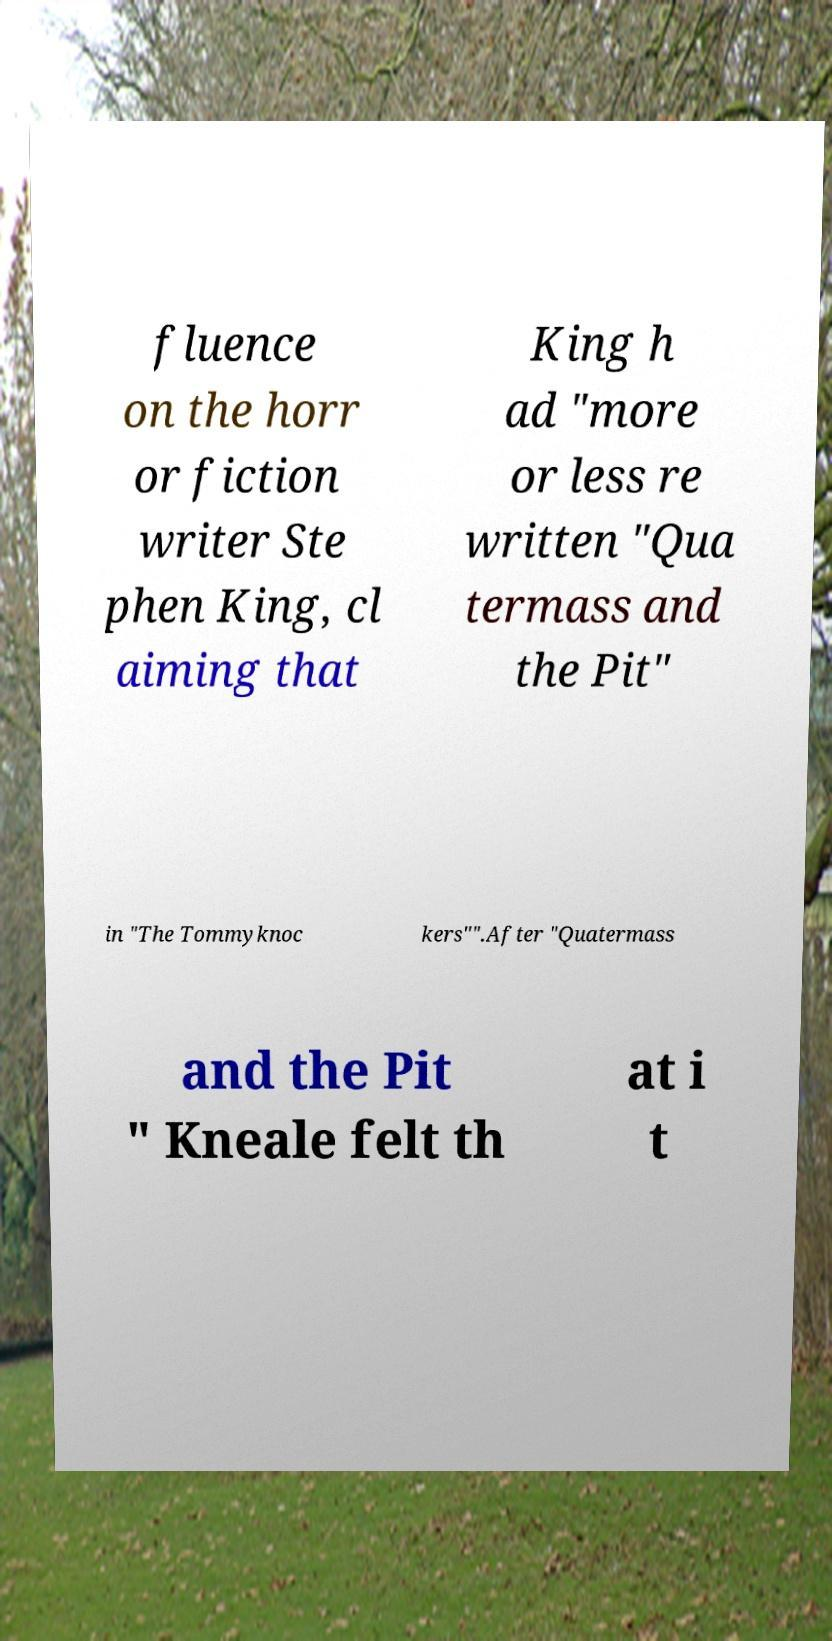Can you accurately transcribe the text from the provided image for me? fluence on the horr or fiction writer Ste phen King, cl aiming that King h ad "more or less re written "Qua termass and the Pit" in "The Tommyknoc kers"".After "Quatermass and the Pit " Kneale felt th at i t 